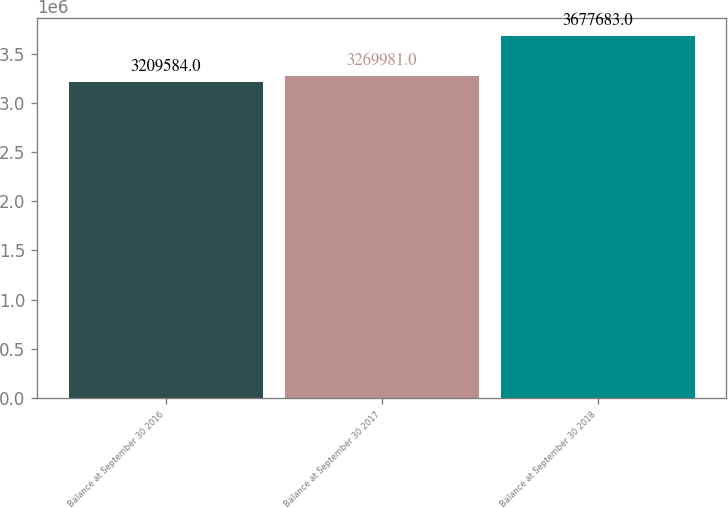Convert chart to OTSL. <chart><loc_0><loc_0><loc_500><loc_500><bar_chart><fcel>Balance at September 30 2016<fcel>Balance at September 30 2017<fcel>Balance at September 30 2018<nl><fcel>3.20958e+06<fcel>3.26998e+06<fcel>3.67768e+06<nl></chart> 